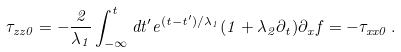Convert formula to latex. <formula><loc_0><loc_0><loc_500><loc_500>\tau _ { z z 0 } = - \frac { 2 } { \lambda _ { 1 } } \int _ { - \infty } ^ { t } d t ^ { \prime } e ^ { ( t - t ^ { \prime } ) / \lambda _ { 1 } } ( 1 + \lambda _ { 2 } \partial _ { t } ) \partial _ { x } f = - \tau _ { x x 0 } \, .</formula> 